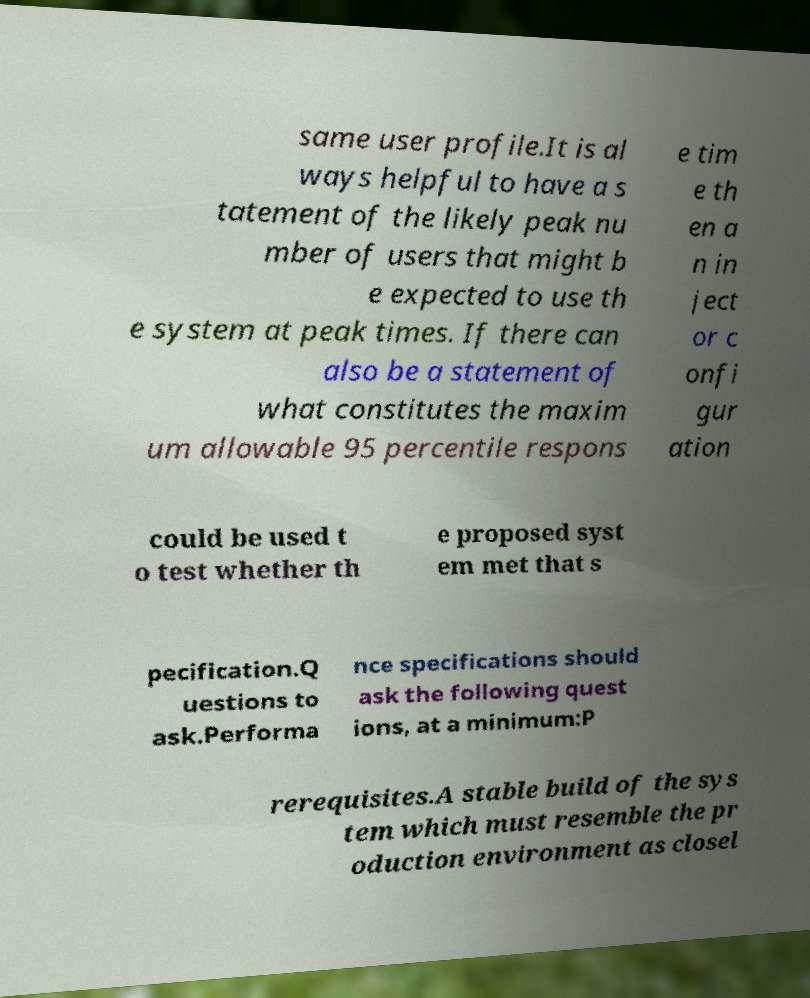For documentation purposes, I need the text within this image transcribed. Could you provide that? same user profile.It is al ways helpful to have a s tatement of the likely peak nu mber of users that might b e expected to use th e system at peak times. If there can also be a statement of what constitutes the maxim um allowable 95 percentile respons e tim e th en a n in ject or c onfi gur ation could be used t o test whether th e proposed syst em met that s pecification.Q uestions to ask.Performa nce specifications should ask the following quest ions, at a minimum:P rerequisites.A stable build of the sys tem which must resemble the pr oduction environment as closel 